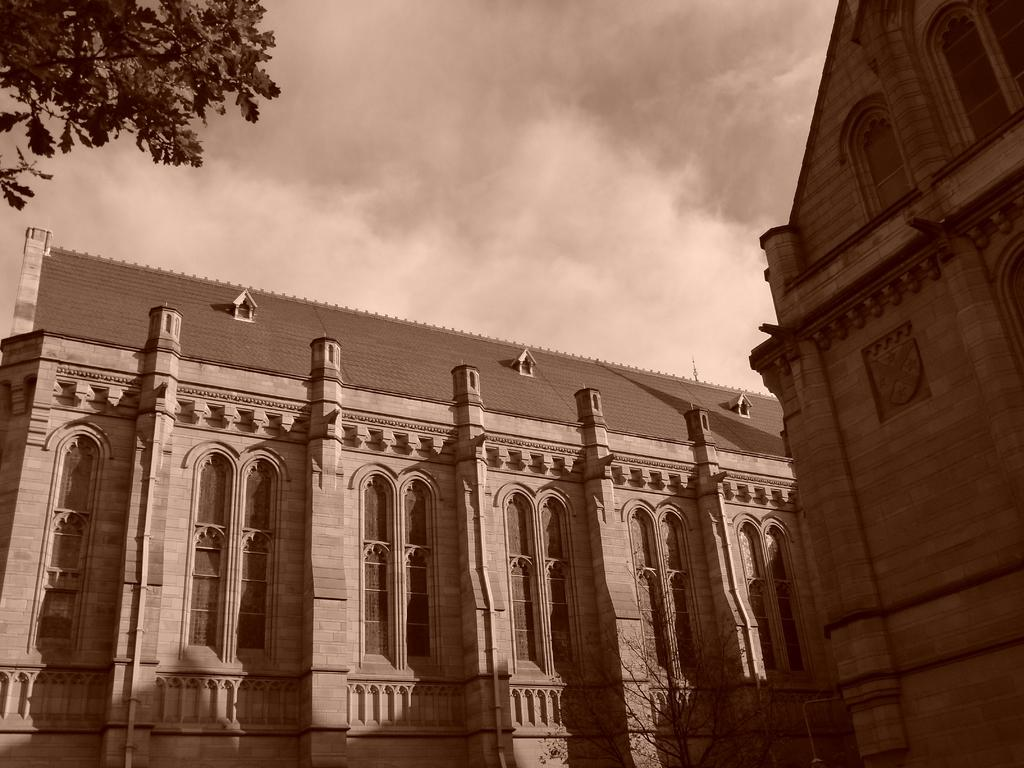What type of structure is present in the image? There is a building in the image. What can be seen in the background of the image? There are trees and the sky visible in the background of the image. What is the color scheme of the image? The image is in black and white. What type of cheese is being served by the daughter in the image? There is no daughter or cheese present in the image. How many trees are visible in the image? The number of trees visible in the image cannot be determined from the provided facts. 